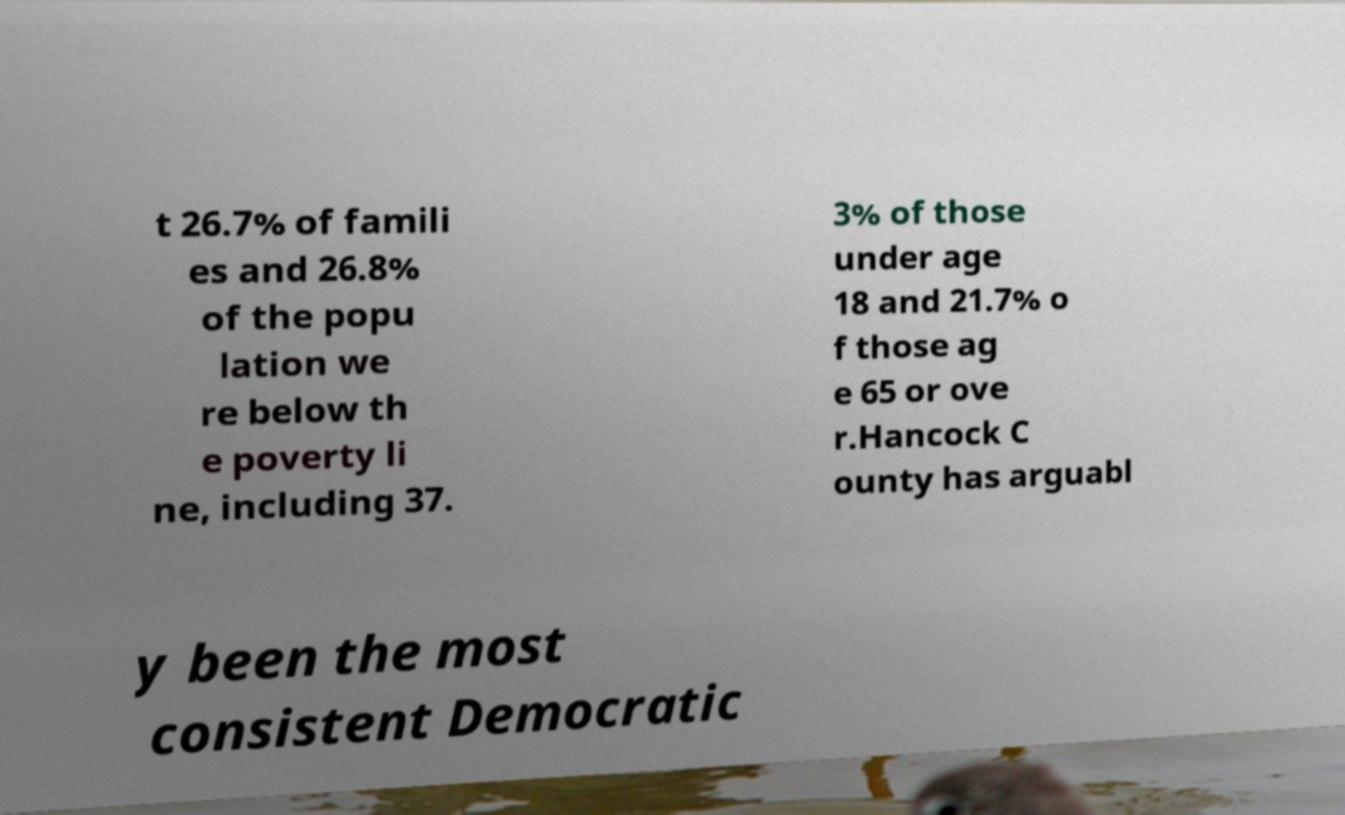Please identify and transcribe the text found in this image. t 26.7% of famili es and 26.8% of the popu lation we re below th e poverty li ne, including 37. 3% of those under age 18 and 21.7% o f those ag e 65 or ove r.Hancock C ounty has arguabl y been the most consistent Democratic 